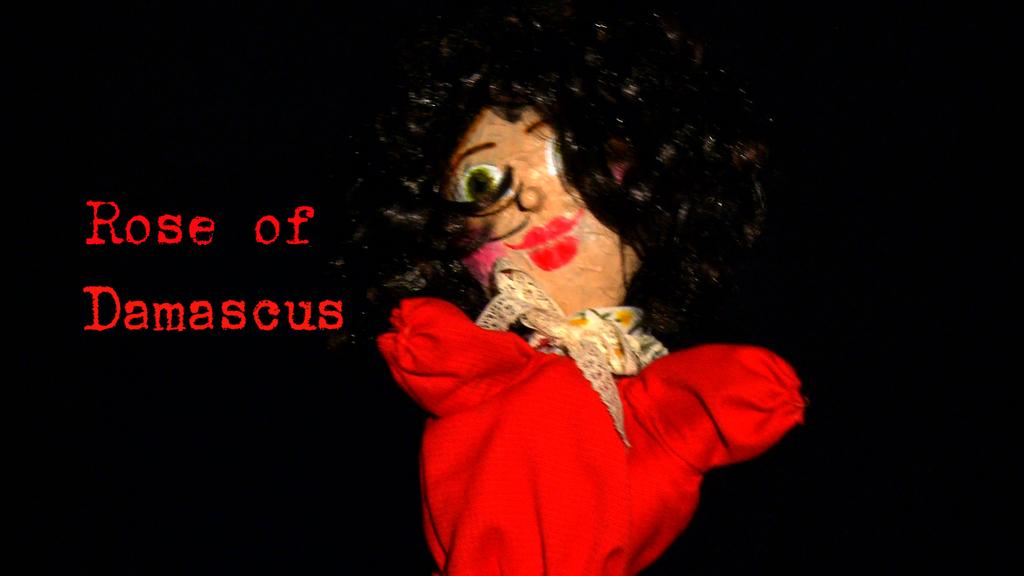What is the main subject in the center of the image? There is a doll in the center of the image. What else can be seen on the right side of the image? There is text on the right side of the image. What type of stage is visible in the background of the image? There is no stage visible in the image; it only features a doll and text. 